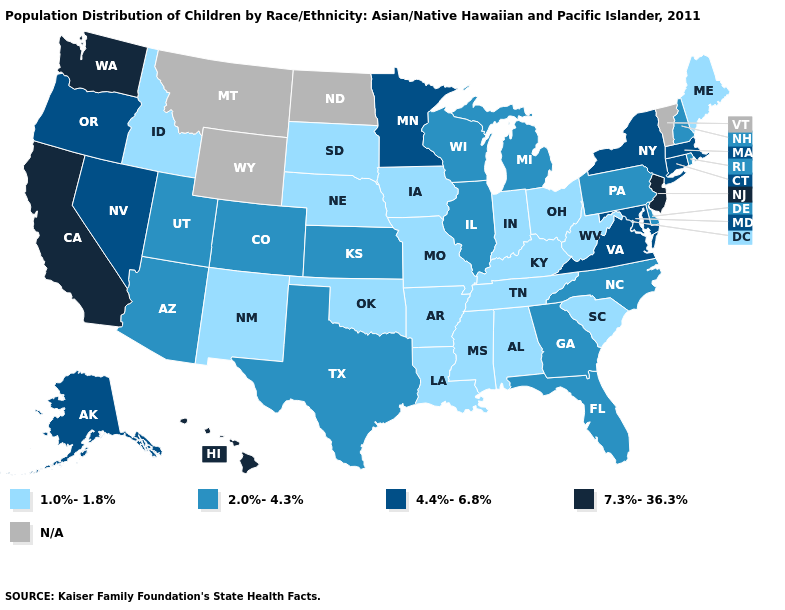What is the highest value in the USA?
Keep it brief. 7.3%-36.3%. What is the value of North Dakota?
Quick response, please. N/A. What is the lowest value in states that border Nevada?
Quick response, please. 1.0%-1.8%. Name the states that have a value in the range 7.3%-36.3%?
Write a very short answer. California, Hawaii, New Jersey, Washington. What is the lowest value in the USA?
Short answer required. 1.0%-1.8%. What is the value of Michigan?
Give a very brief answer. 2.0%-4.3%. Does the map have missing data?
Concise answer only. Yes. Is the legend a continuous bar?
Answer briefly. No. Name the states that have a value in the range 7.3%-36.3%?
Write a very short answer. California, Hawaii, New Jersey, Washington. What is the lowest value in states that border Louisiana?
Concise answer only. 1.0%-1.8%. What is the value of Minnesota?
Be succinct. 4.4%-6.8%. What is the value of Hawaii?
Be succinct. 7.3%-36.3%. Name the states that have a value in the range 1.0%-1.8%?
Keep it brief. Alabama, Arkansas, Idaho, Indiana, Iowa, Kentucky, Louisiana, Maine, Mississippi, Missouri, Nebraska, New Mexico, Ohio, Oklahoma, South Carolina, South Dakota, Tennessee, West Virginia. Among the states that border Massachusetts , does New Hampshire have the highest value?
Quick response, please. No. Does Iowa have the highest value in the MidWest?
Write a very short answer. No. 